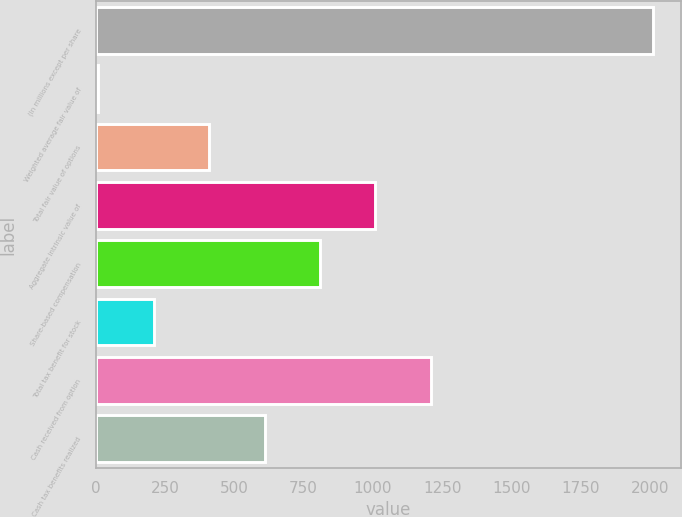Convert chart. <chart><loc_0><loc_0><loc_500><loc_500><bar_chart><fcel>(In millions except per share<fcel>Weighted average fair value of<fcel>Total fair value of options<fcel>Aggregate intrinsic value of<fcel>Share-based compensation<fcel>Total tax benefit for stock<fcel>Cash received from option<fcel>Cash tax benefits realized<nl><fcel>2010<fcel>8.73<fcel>408.99<fcel>1009.38<fcel>809.25<fcel>208.86<fcel>1209.51<fcel>609.12<nl></chart> 